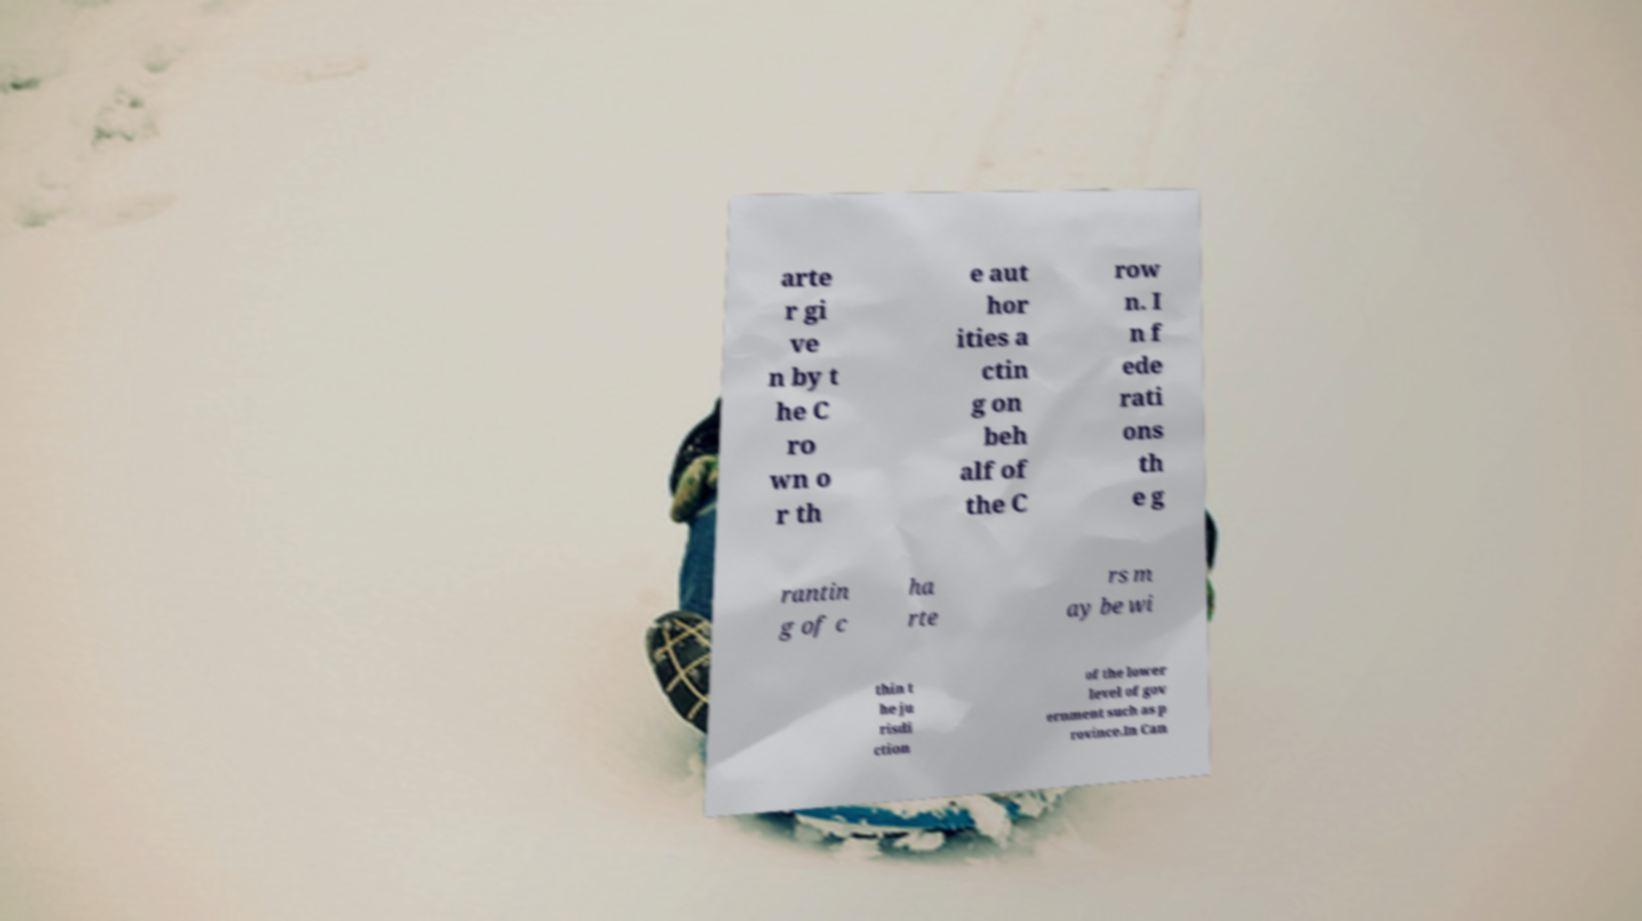Could you extract and type out the text from this image? arte r gi ve n by t he C ro wn o r th e aut hor ities a ctin g on beh alf of the C row n. I n f ede rati ons th e g rantin g of c ha rte rs m ay be wi thin t he ju risdi ction of the lower level of gov ernment such as p rovince.In Can 